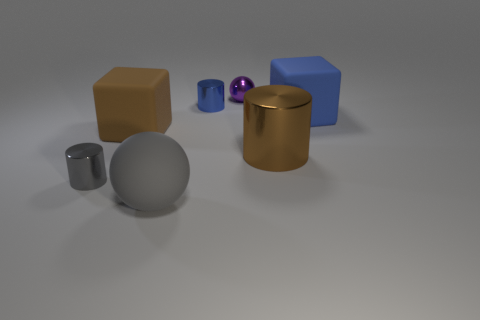Subtract all gray cylinders. Subtract all cyan spheres. How many cylinders are left? 2 Add 2 shiny balls. How many objects exist? 9 Subtract all cylinders. How many objects are left? 4 Subtract 1 gray cylinders. How many objects are left? 6 Subtract all big blocks. Subtract all big rubber balls. How many objects are left? 4 Add 6 tiny purple balls. How many tiny purple balls are left? 7 Add 1 purple balls. How many purple balls exist? 2 